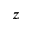Convert formula to latex. <formula><loc_0><loc_0><loc_500><loc_500>z</formula> 